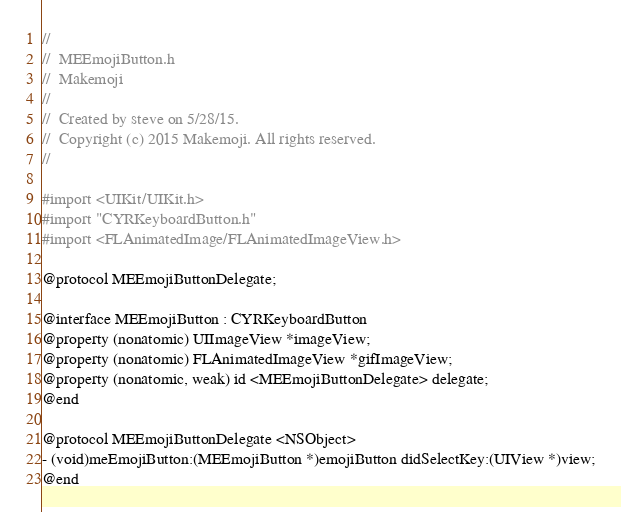Convert code to text. <code><loc_0><loc_0><loc_500><loc_500><_C_>//
//  MEEmojiButton.h
//  Makemoji
//
//  Created by steve on 5/28/15.
//  Copyright (c) 2015 Makemoji. All rights reserved.
//

#import <UIKit/UIKit.h>
#import "CYRKeyboardButton.h"
#import <FLAnimatedImage/FLAnimatedImageView.h>

@protocol MEEmojiButtonDelegate;

@interface MEEmojiButton : CYRKeyboardButton
@property (nonatomic) UIImageView *imageView;
@property (nonatomic) FLAnimatedImageView *gifImageView;
@property (nonatomic, weak) id <MEEmojiButtonDelegate> delegate;
@end

@protocol MEEmojiButtonDelegate <NSObject>
- (void)meEmojiButton:(MEEmojiButton *)emojiButton didSelectKey:(UIView *)view;
@end
</code> 